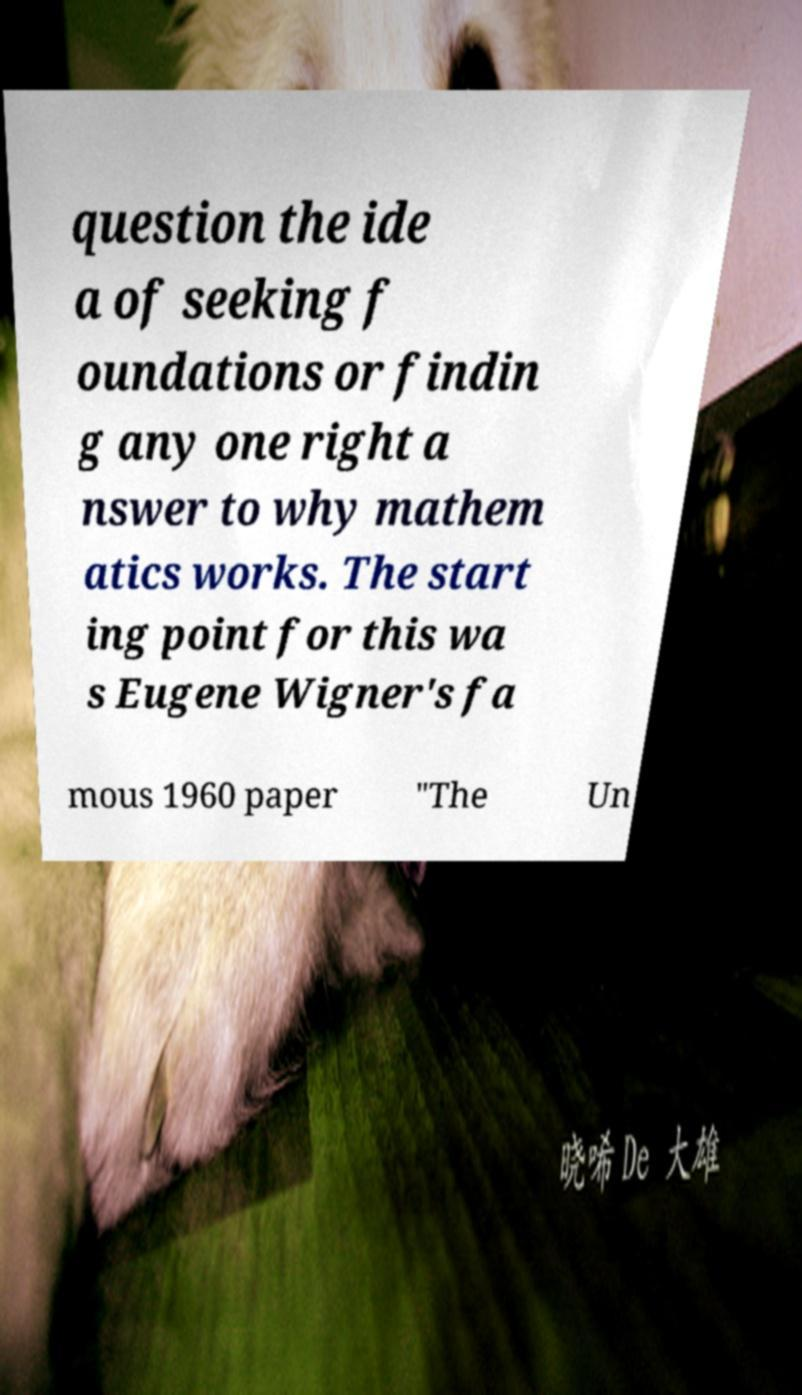For documentation purposes, I need the text within this image transcribed. Could you provide that? question the ide a of seeking f oundations or findin g any one right a nswer to why mathem atics works. The start ing point for this wa s Eugene Wigner's fa mous 1960 paper "The Un 